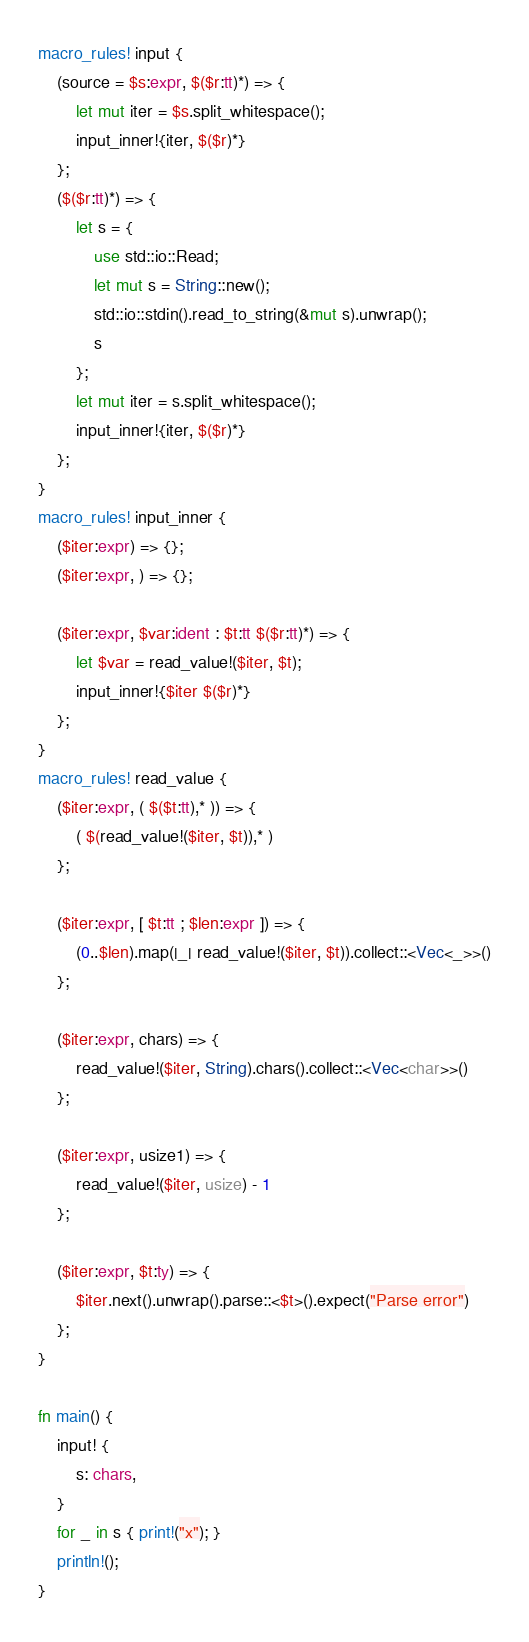<code> <loc_0><loc_0><loc_500><loc_500><_Rust_>macro_rules! input {
    (source = $s:expr, $($r:tt)*) => {
        let mut iter = $s.split_whitespace();
        input_inner!{iter, $($r)*}
    };
    ($($r:tt)*) => {
        let s = {
            use std::io::Read;
            let mut s = String::new();
            std::io::stdin().read_to_string(&mut s).unwrap();
            s
        };
        let mut iter = s.split_whitespace();
        input_inner!{iter, $($r)*}
    };
}
macro_rules! input_inner {
    ($iter:expr) => {};
    ($iter:expr, ) => {};

    ($iter:expr, $var:ident : $t:tt $($r:tt)*) => {
        let $var = read_value!($iter, $t);
        input_inner!{$iter $($r)*}
    };
}
macro_rules! read_value {
    ($iter:expr, ( $($t:tt),* )) => {
        ( $(read_value!($iter, $t)),* )
    };

    ($iter:expr, [ $t:tt ; $len:expr ]) => {
        (0..$len).map(|_| read_value!($iter, $t)).collect::<Vec<_>>()
    };

    ($iter:expr, chars) => {
        read_value!($iter, String).chars().collect::<Vec<char>>()
    };

    ($iter:expr, usize1) => {
        read_value!($iter, usize) - 1
    };

    ($iter:expr, $t:ty) => {
        $iter.next().unwrap().parse::<$t>().expect("Parse error")
    };
}

fn main() {
    input! {
        s: chars,
    }
    for _ in s { print!("x"); }
    println!();
}
</code> 